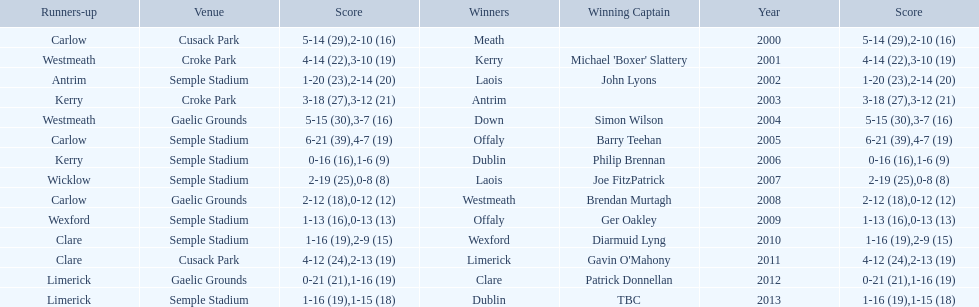Who was the first winner in 2013? Dublin. 